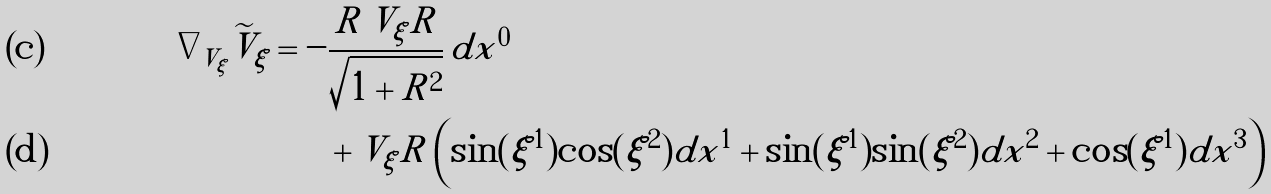<formula> <loc_0><loc_0><loc_500><loc_500>\nabla _ { V _ { \xi } } \widetilde { V } _ { \xi } = - & \frac { R \, V _ { \xi } R } { \sqrt { 1 + R ^ { 2 } } } \, d x ^ { 0 } \\ & + V _ { \xi } R \left ( \sin ( \xi ^ { 1 } ) \cos ( \xi ^ { 2 } ) d x ^ { 1 } + \sin ( \xi ^ { 1 } ) \sin ( \xi ^ { 2 } ) d x ^ { 2 } + \cos ( \xi ^ { 1 } ) d x ^ { 3 } \right )</formula> 